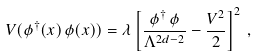Convert formula to latex. <formula><loc_0><loc_0><loc_500><loc_500>V ( \phi ^ { \dagger } ( x ) \, \phi ( x ) ) = \lambda \left [ \frac { \phi ^ { \dagger } \, \phi } { \Lambda ^ { 2 d - 2 } } - \frac { V ^ { 2 } } { 2 } \right ] ^ { 2 } \, ,</formula> 